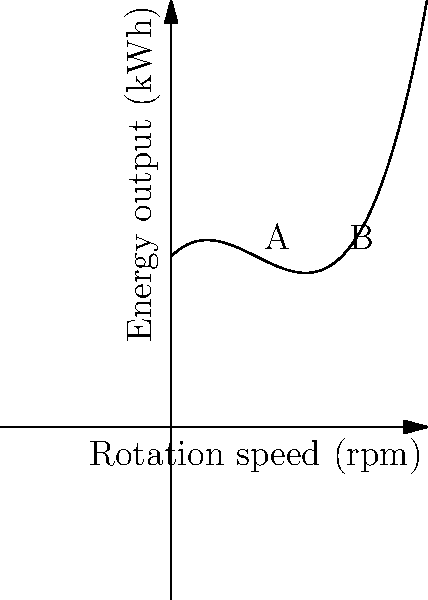The graph shows the relationship between the rotation speed of wind turbine blades and energy output. Point A represents the current operating condition, while point B represents a proposed change. Calculate the percentage increase in energy output if the rotation speed is increased from point A to point B. How might this change impact the surrounding ecosystem and the psychological well-being of nearby residents? To solve this problem, we need to follow these steps:

1. Identify the energy output at points A and B:
   Point A (1 rpm): $f(1) = 0.5(1)^3 - 1.5(1)^2 + 1 + 2 = 2$ kWh
   Point B (2 rpm): $f(2) = 0.5(2)^3 - 1.5(2)^2 + 2 + 2 = 3$ kWh

2. Calculate the increase in energy output:
   Increase = $3 - 2 = 1$ kWh

3. Calculate the percentage increase:
   Percentage increase = $\frac{\text{Increase}}{\text{Original}} \times 100\%$
   $= \frac{1}{2} \times 100\% = 50\%$

4. Consider the impact on the ecosystem and psychological well-being:
   a. Increased noise levels may disturb local wildlife and residents.
   b. Faster blade rotation could pose a greater risk to birds and bats.
   c. Visual impact may be more pronounced, affecting the landscape aesthetics.
   d. Improved energy output could lead to reduced reliance on fossil fuels, potentially improving air quality and reducing climate anxiety.
   e. The trade-off between clean energy production and immediate environmental impact may cause mixed feelings among residents, affecting their psychological well-being.
Answer: 50% increase; potential negative impacts on wildlife and noise levels, but positive effects on clean energy production and climate anxiety reduction. 